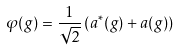<formula> <loc_0><loc_0><loc_500><loc_500>\varphi ( g ) = \frac { 1 } { \sqrt { 2 } } \left ( a ^ { * } ( g ) + a ( g ) \right )</formula> 